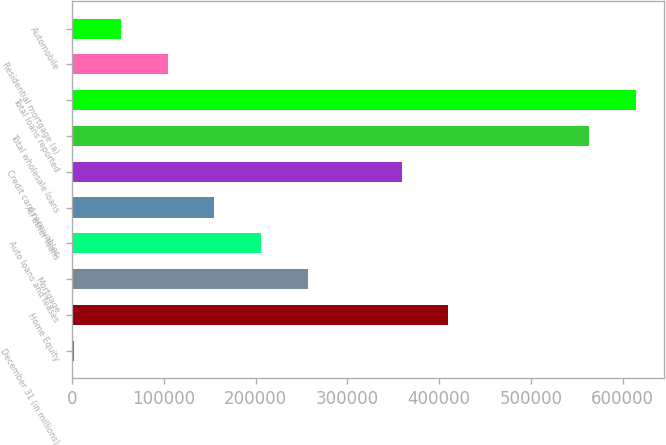<chart> <loc_0><loc_0><loc_500><loc_500><bar_chart><fcel>December 31 (in millions)<fcel>Home Equity<fcel>Mortgage<fcel>Auto loans and leases<fcel>All other loans<fcel>Credit card receivables<fcel>Total wholesale loans<fcel>Total loans reported<fcel>Residential mortgage (a)<fcel>Automobile<nl><fcel>2005<fcel>410180<fcel>257114<fcel>206093<fcel>155071<fcel>359158<fcel>563246<fcel>614268<fcel>104049<fcel>53026.9<nl></chart> 